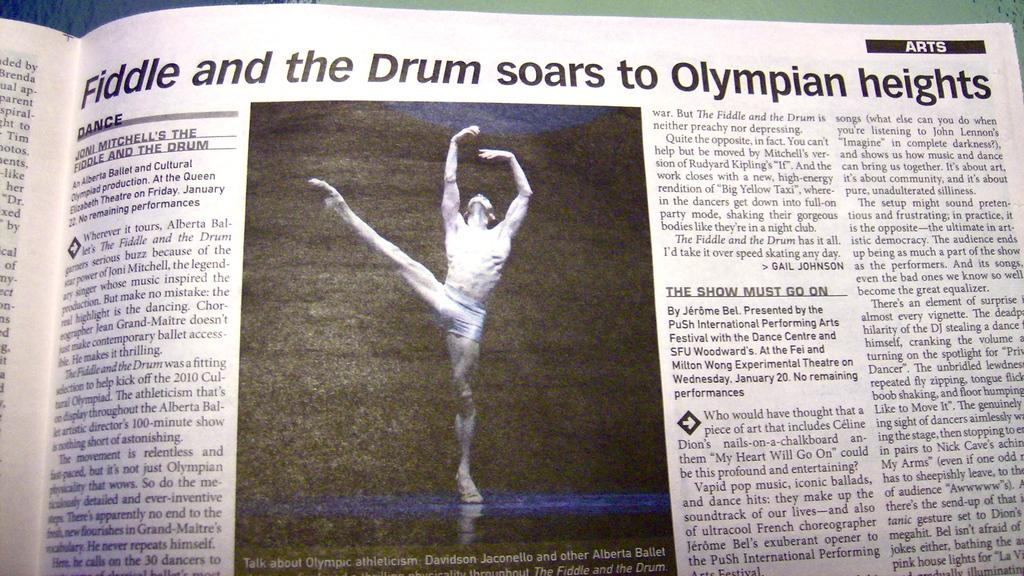<image>
Offer a succinct explanation of the picture presented. A newspaper is open to a story about an Olympian. 